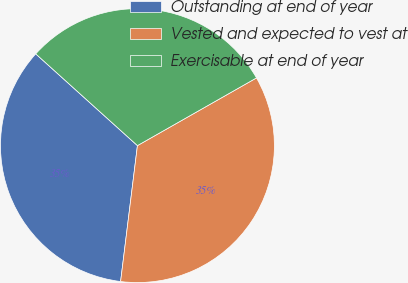Convert chart to OTSL. <chart><loc_0><loc_0><loc_500><loc_500><pie_chart><fcel>Outstanding at end of year<fcel>Vested and expected to vest at<fcel>Exercisable at end of year<nl><fcel>34.72%<fcel>35.19%<fcel>30.09%<nl></chart> 